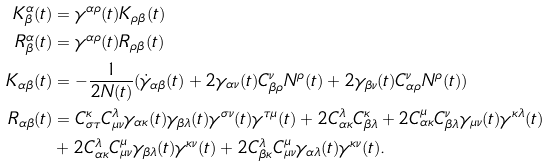Convert formula to latex. <formula><loc_0><loc_0><loc_500><loc_500>K ^ { \alpha } _ { \beta } ( t ) & = \gamma ^ { \alpha \rho } ( t ) K _ { \rho \beta } ( t ) \\ R ^ { \alpha } _ { \beta } ( t ) & = \gamma ^ { \alpha \rho } ( t ) R _ { \rho \beta } ( t ) \\ K _ { \alpha \beta } ( t ) & = - \frac { 1 } { 2 N ( t ) } ( \dot { \gamma } _ { \alpha \beta } ( t ) + 2 \gamma _ { \alpha \nu } ( t ) C ^ { \nu } _ { \beta \rho } N ^ { \rho } ( t ) + 2 \gamma _ { \beta \nu } ( t ) C ^ { \nu } _ { \alpha \rho } N ^ { \rho } ( t ) ) \\ R _ { \alpha \beta } ( t ) & = C ^ { \kappa } _ { \sigma \tau } C ^ { \lambda } _ { \mu \nu } \gamma _ { \alpha \kappa } ( t ) \gamma _ { \beta \lambda } ( t ) \gamma ^ { \sigma \nu } ( t ) \gamma ^ { \tau \mu } ( t ) + 2 C ^ { \lambda } _ { \alpha \kappa } C ^ { \kappa } _ { \beta \lambda } + 2 C ^ { \mu } _ { \alpha \kappa } C ^ { \nu } _ { \beta \lambda } \gamma _ { \mu \nu } ( t ) \gamma ^ { \kappa \lambda } ( t ) \\ & + 2 C ^ { \lambda } _ { \alpha \kappa } C ^ { \mu } _ { \mu \nu } \gamma _ { \beta \lambda } ( t ) \gamma ^ { \kappa \nu } ( t ) + 2 C ^ { \lambda } _ { \beta \kappa } C ^ { \mu } _ { \mu \nu } \gamma _ { \alpha \lambda } ( t ) \gamma ^ { \kappa \nu } ( t ) .</formula> 